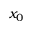<formula> <loc_0><loc_0><loc_500><loc_500>x _ { 0 }</formula> 